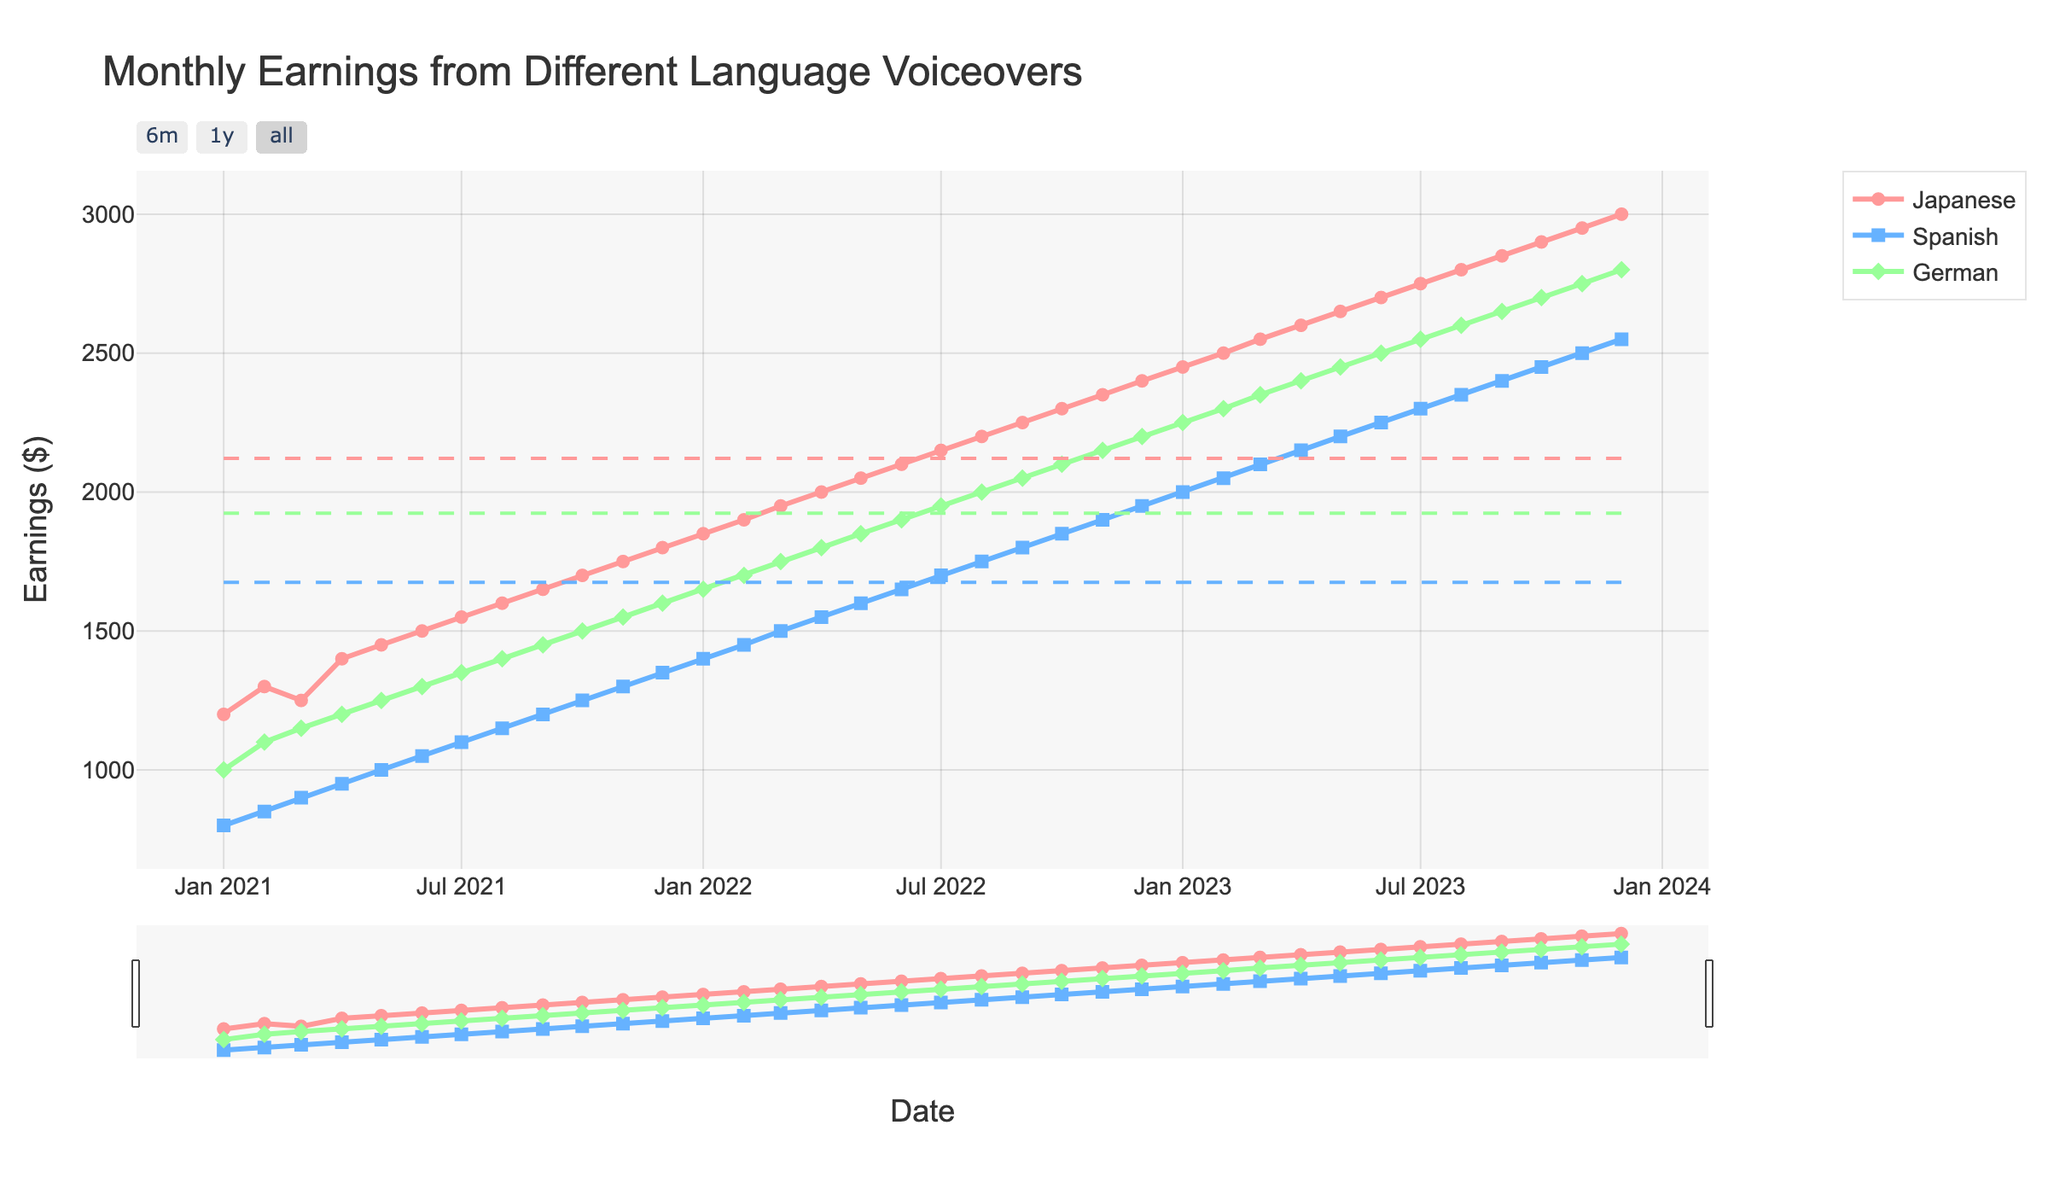What is the title of the plot? The title of the plot is usually found at the top of the figure. It gives a summary of what the plot is about.
Answer: Monthly Earnings from Different Language Voiceovers Which language had the highest earnings in December 2023? Look at the data points for December 2023 and compare the earnings for Japanese, Spanish, and German. The highest point will indicate the language with the highest earnings.
Answer: Japanese What is the average monthly earning for Spanish voiceovers over the past two years? Sum the monthly earnings for Spanish over the two years and divide by the number of months (24). The average is calculated as (800 + 850 + ... + 2450 + 2550) / 24.
Answer: 1675 How did the earnings for German voiceovers change from January 2021 to December 2023? Compare the earnings for German in January 2021 (1000) and December 2023 (2800).
Answer: Increased by 1800 In which month did Japanese voiceovers first exceed $2000? Identify the month when the Japanese earnings first crossed the $2000 mark. Look at the earnings for Japanese and see when they reach above $2000. Here, it started exceeding $2000 in April 2022.
Answer: April 2022 Which language showed the most consistent growth trend over the two years? Compare the trend lines for the three languages. The consistency can be judged by the steadiness of the increase without significant dips or fluctuations. Notice the direction and the slopes of each line.
Answer: Japanese During which month did Spanish earnings experience the highest month-over-month increase? Calculate the month-over-month increase for Spanish from each month to the next. Identify the month with the highest difference.
Answer: July 2023 What are the mean earnings for German voiceovers, as represented by the dashed line? Locate the dashed line representing the mean across the plot for German voiceovers.
Answer: $1875 Compare the earnings growth rate of the Japanese and Spanish voiceovers from January 2021 to October 2023. Calculate the total increase for Japanese ($2900 - $1200 = $1700) and Spanish ($2450 - $800 = $1650) from January 2021 to October 2023. Compare the two values.
Answer: Japanese grew slightly more 